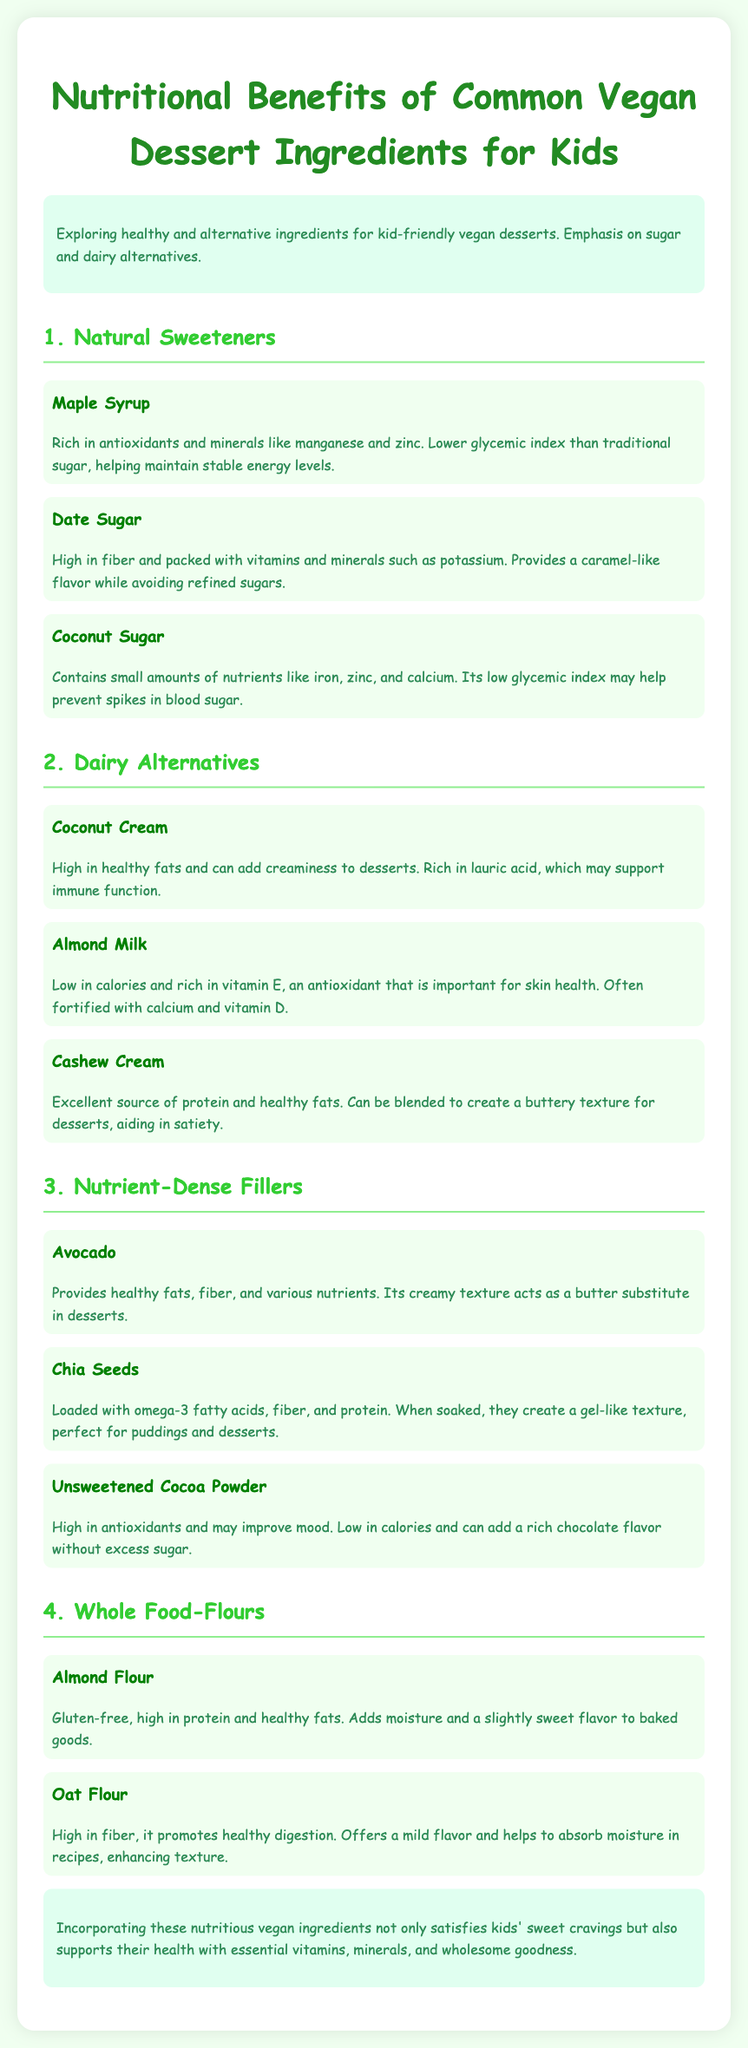What is the first ingredient listed under natural sweeteners? The first ingredient listed is Maple Syrup.
Answer: Maple Syrup How many natural sweeteners are mentioned in the document? There are three natural sweeteners mentioned: Maple Syrup, Date Sugar, and Coconut Sugar.
Answer: Three Which dairy alternative is rich in healthy fats? Coconut Cream is highlighted for being high in healthy fats.
Answer: Coconut Cream What nutrient is Chia Seeds particularly high in? Chia Seeds are loaded with omega-3 fatty acids.
Answer: Omega-3 fatty acids Which flour is gluten-free? Almond Flour is specified as gluten-free.
Answer: Almond Flour What type of ingredient is noted for adding a creamy texture in vegan desserts? Avocado is noted for its creamy texture.
Answer: Avocado Which ingredient provides a caramel-like flavor without refined sugars? Date Sugar provides a caramel-like flavor while avoiding refined sugars.
Answer: Date Sugar How many nutrient-dense fillers are listed in the document? There are three nutrient-dense fillers mentioned: Avocado, Chia Seeds, and Unsweetened Cocoa Powder.
Answer: Three 